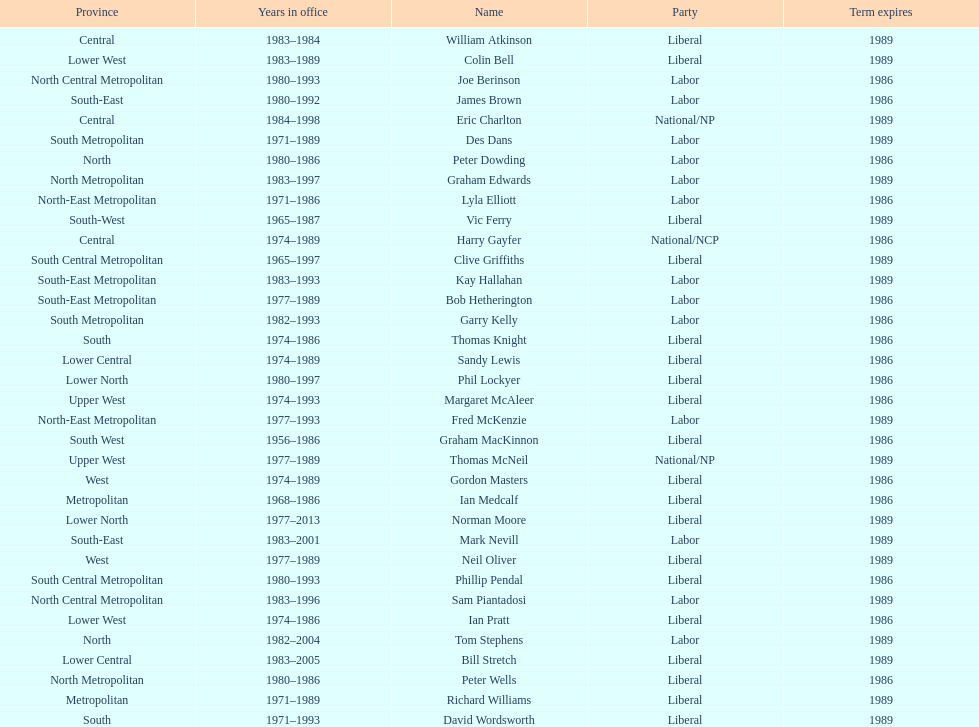Could you parse the entire table? {'header': ['Province', 'Years in office', 'Name', 'Party', 'Term expires'], 'rows': [['Central', '1983–1984', 'William Atkinson', 'Liberal', '1989'], ['Lower West', '1983–1989', 'Colin Bell', 'Liberal', '1989'], ['North Central Metropolitan', '1980–1993', 'Joe Berinson', 'Labor', '1986'], ['South-East', '1980–1992', 'James Brown', 'Labor', '1986'], ['Central', '1984–1998', 'Eric Charlton', 'National/NP', '1989'], ['South Metropolitan', '1971–1989', 'Des Dans', 'Labor', '1989'], ['North', '1980–1986', 'Peter Dowding', 'Labor', '1986'], ['North Metropolitan', '1983–1997', 'Graham Edwards', 'Labor', '1989'], ['North-East Metropolitan', '1971–1986', 'Lyla Elliott', 'Labor', '1986'], ['South-West', '1965–1987', 'Vic Ferry', 'Liberal', '1989'], ['Central', '1974–1989', 'Harry Gayfer', 'National/NCP', '1986'], ['South Central Metropolitan', '1965–1997', 'Clive Griffiths', 'Liberal', '1989'], ['South-East Metropolitan', '1983–1993', 'Kay Hallahan', 'Labor', '1989'], ['South-East Metropolitan', '1977–1989', 'Bob Hetherington', 'Labor', '1986'], ['South Metropolitan', '1982–1993', 'Garry Kelly', 'Labor', '1986'], ['South', '1974–1986', 'Thomas Knight', 'Liberal', '1986'], ['Lower Central', '1974–1989', 'Sandy Lewis', 'Liberal', '1986'], ['Lower North', '1980–1997', 'Phil Lockyer', 'Liberal', '1986'], ['Upper West', '1974–1993', 'Margaret McAleer', 'Liberal', '1986'], ['North-East Metropolitan', '1977–1993', 'Fred McKenzie', 'Labor', '1989'], ['South West', '1956–1986', 'Graham MacKinnon', 'Liberal', '1986'], ['Upper West', '1977–1989', 'Thomas McNeil', 'National/NP', '1989'], ['West', '1974–1989', 'Gordon Masters', 'Liberal', '1986'], ['Metropolitan', '1968–1986', 'Ian Medcalf', 'Liberal', '1986'], ['Lower North', '1977–2013', 'Norman Moore', 'Liberal', '1989'], ['South-East', '1983–2001', 'Mark Nevill', 'Labor', '1989'], ['West', '1977–1989', 'Neil Oliver', 'Liberal', '1989'], ['South Central Metropolitan', '1980–1993', 'Phillip Pendal', 'Liberal', '1986'], ['North Central Metropolitan', '1983–1996', 'Sam Piantadosi', 'Labor', '1989'], ['Lower West', '1974–1986', 'Ian Pratt', 'Liberal', '1986'], ['North', '1982–2004', 'Tom Stephens', 'Labor', '1989'], ['Lower Central', '1983–2005', 'Bill Stretch', 'Liberal', '1989'], ['North Metropolitan', '1980–1986', 'Peter Wells', 'Liberal', '1986'], ['Metropolitan', '1971–1989', 'Richard Williams', 'Liberal', '1989'], ['South', '1971–1993', 'David Wordsworth', 'Liberal', '1989']]} What is the total number of members whose term expires in 1989? 9. 